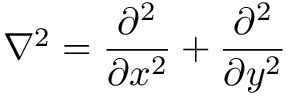<formula> <loc_0><loc_0><loc_500><loc_500>\nabla ^ { 2 } = \frac { \partial ^ { 2 } } { \partial x ^ { 2 } } + \frac { \partial ^ { 2 } } { \partial y ^ { 2 } }</formula> 